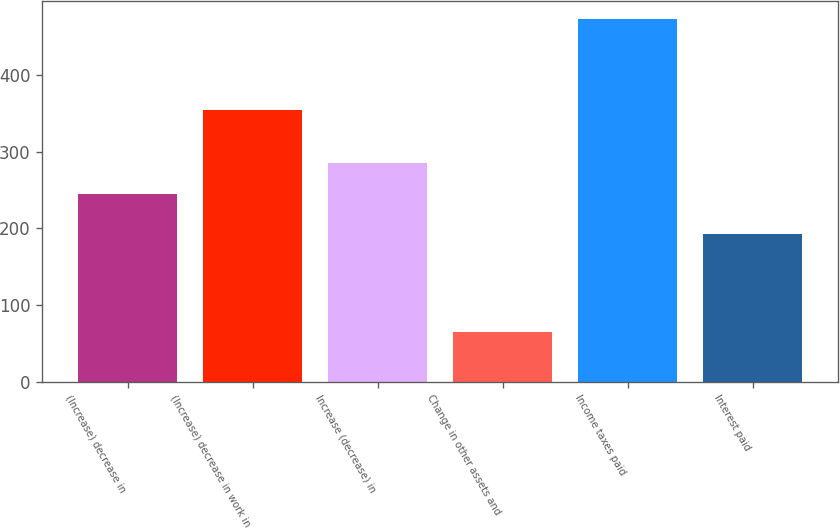Convert chart to OTSL. <chart><loc_0><loc_0><loc_500><loc_500><bar_chart><fcel>(Increase) decrease in<fcel>(Increase) decrease in work in<fcel>Increase (decrease) in<fcel>Change in other assets and<fcel>Income taxes paid<fcel>Interest paid<nl><fcel>244.8<fcel>354.5<fcel>285.55<fcel>64.9<fcel>472.4<fcel>192.8<nl></chart> 